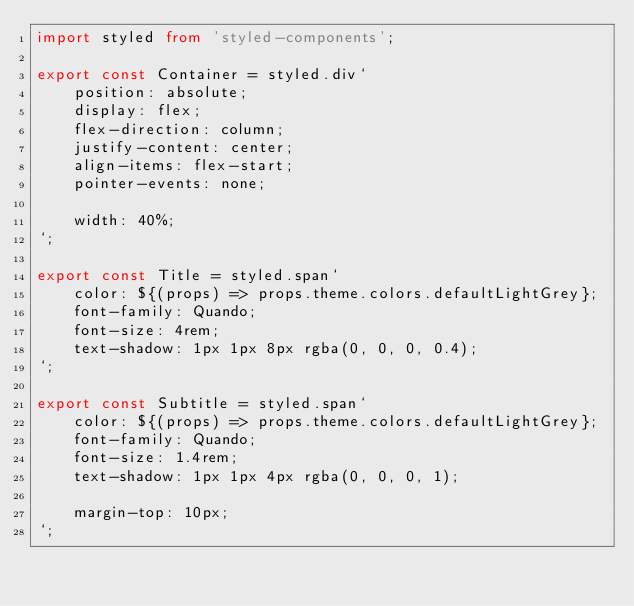Convert code to text. <code><loc_0><loc_0><loc_500><loc_500><_TypeScript_>import styled from 'styled-components';

export const Container = styled.div`
    position: absolute;
    display: flex;
    flex-direction: column;
    justify-content: center;
    align-items: flex-start;
    pointer-events: none;

    width: 40%;
`;

export const Title = styled.span`
    color: ${(props) => props.theme.colors.defaultLightGrey};
    font-family: Quando;
    font-size: 4rem;
    text-shadow: 1px 1px 8px rgba(0, 0, 0, 0.4);
`;

export const Subtitle = styled.span`
    color: ${(props) => props.theme.colors.defaultLightGrey};
    font-family: Quando;
    font-size: 1.4rem;
    text-shadow: 1px 1px 4px rgba(0, 0, 0, 1);

    margin-top: 10px;
`;
</code> 